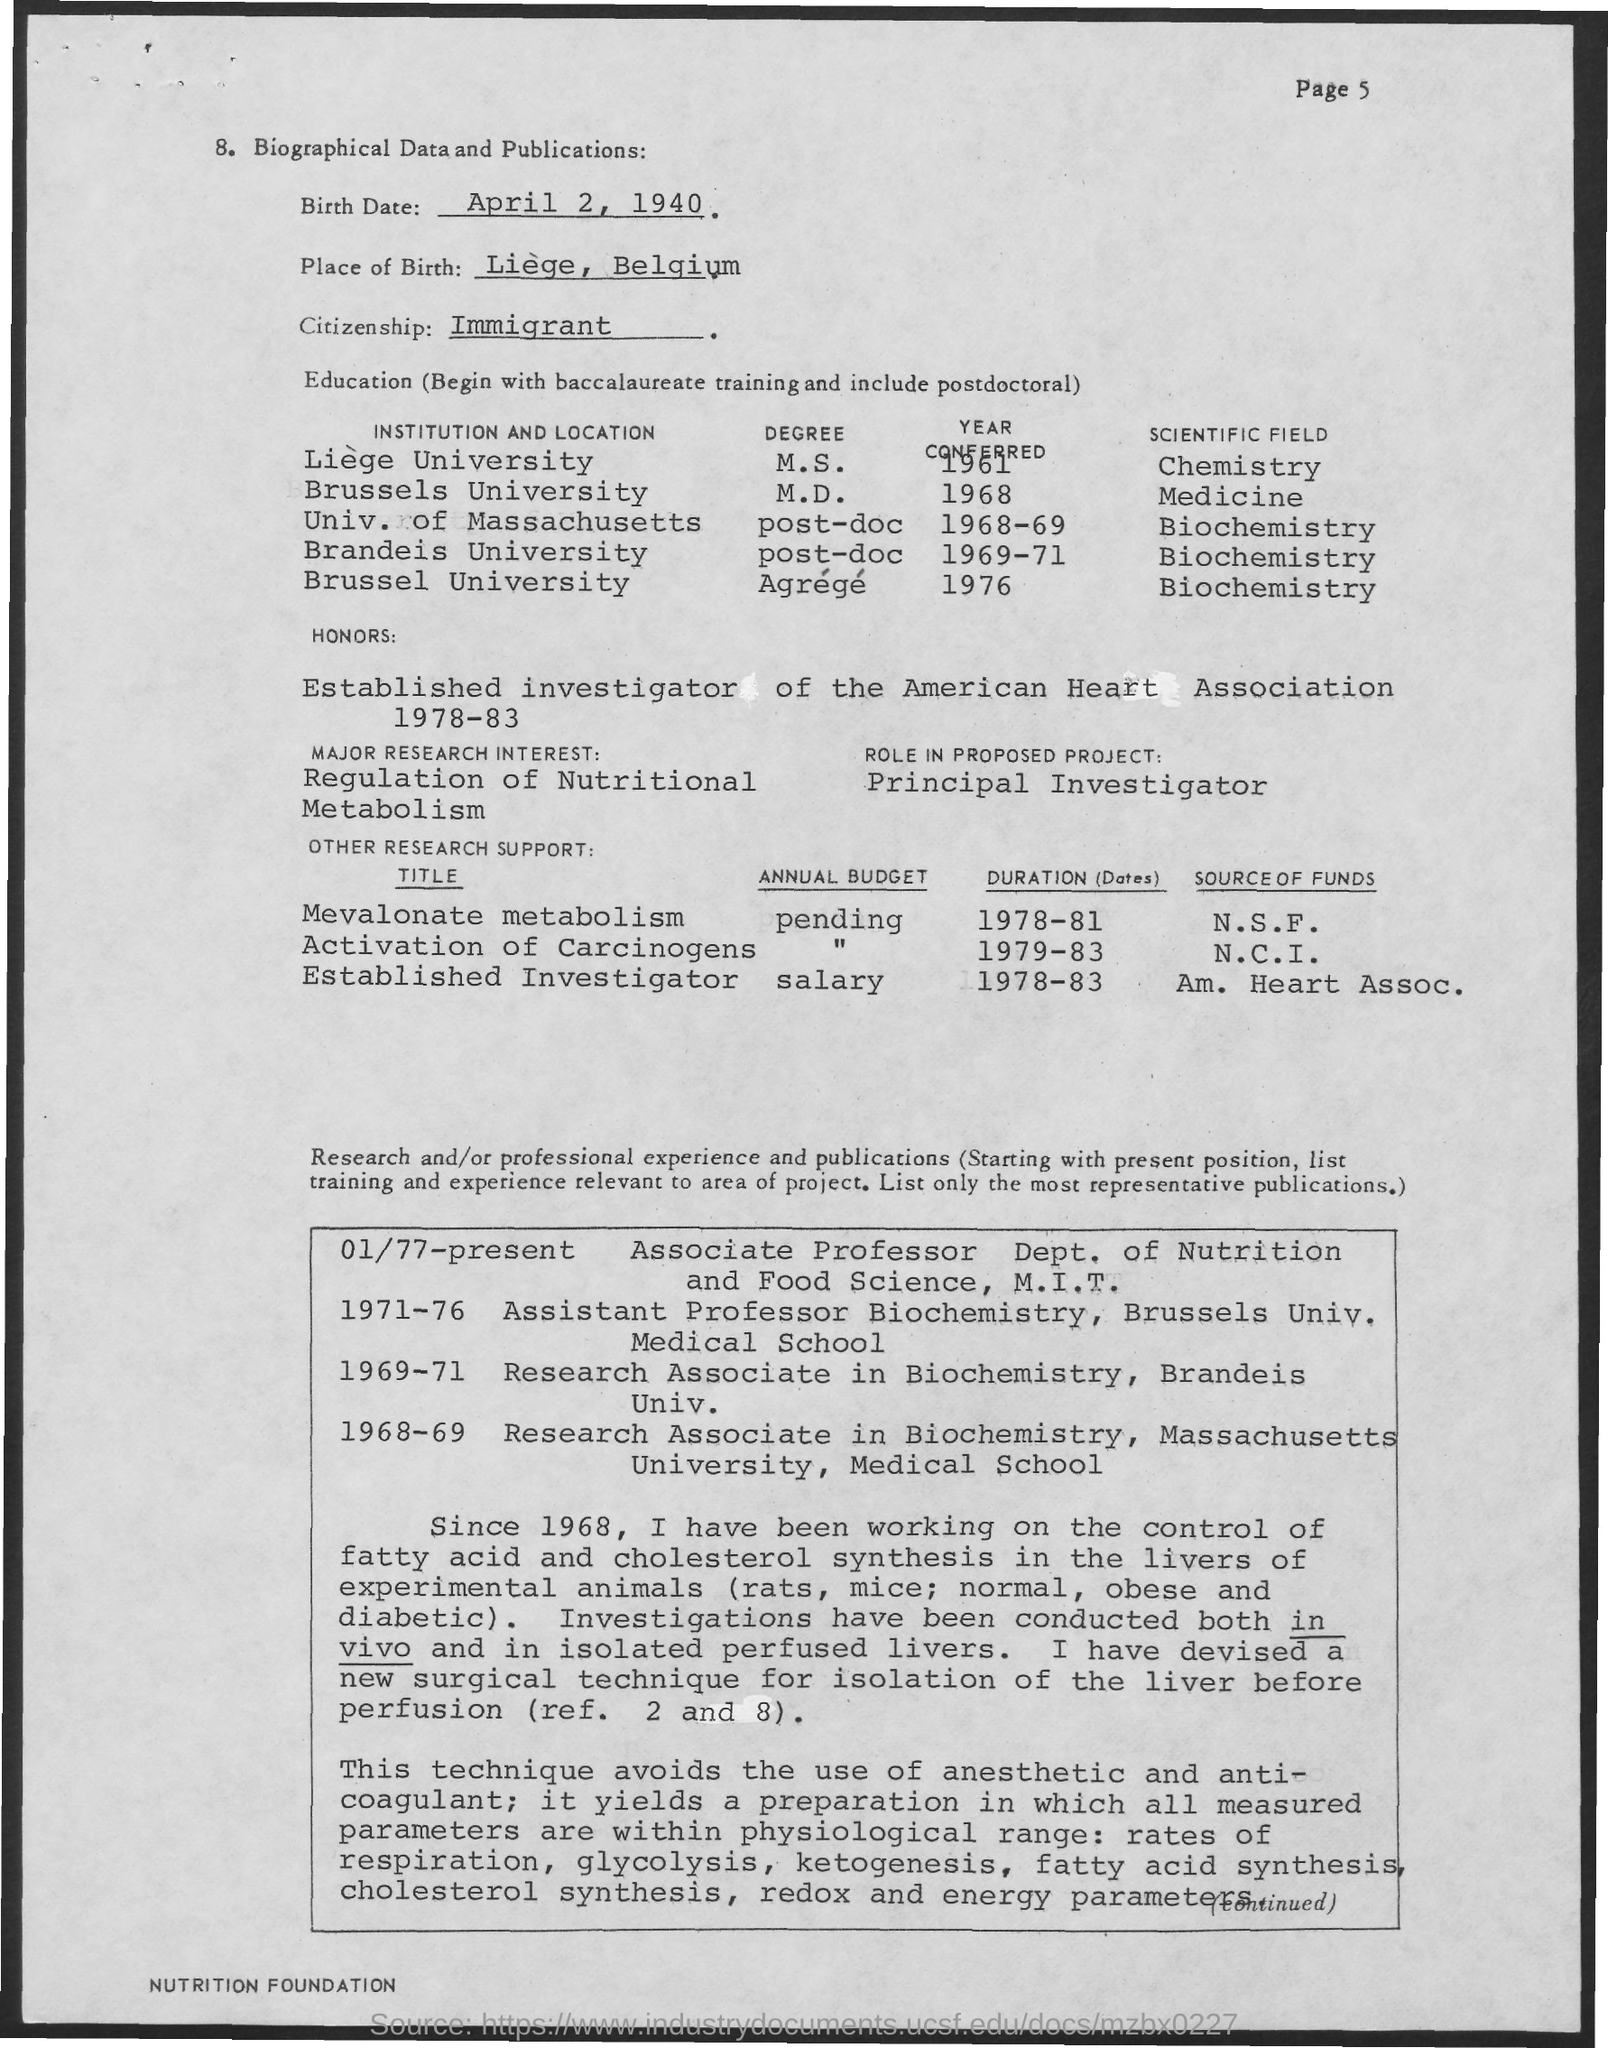What is the date of birth mentioned in this document?
Provide a succinct answer. April 2, 1940. What is the citizenship of the person this document belongs to?
Your response must be concise. Immigrant. What is the place of birth of the person this document belongs to?
Give a very brief answer. Liege, Belgium. 